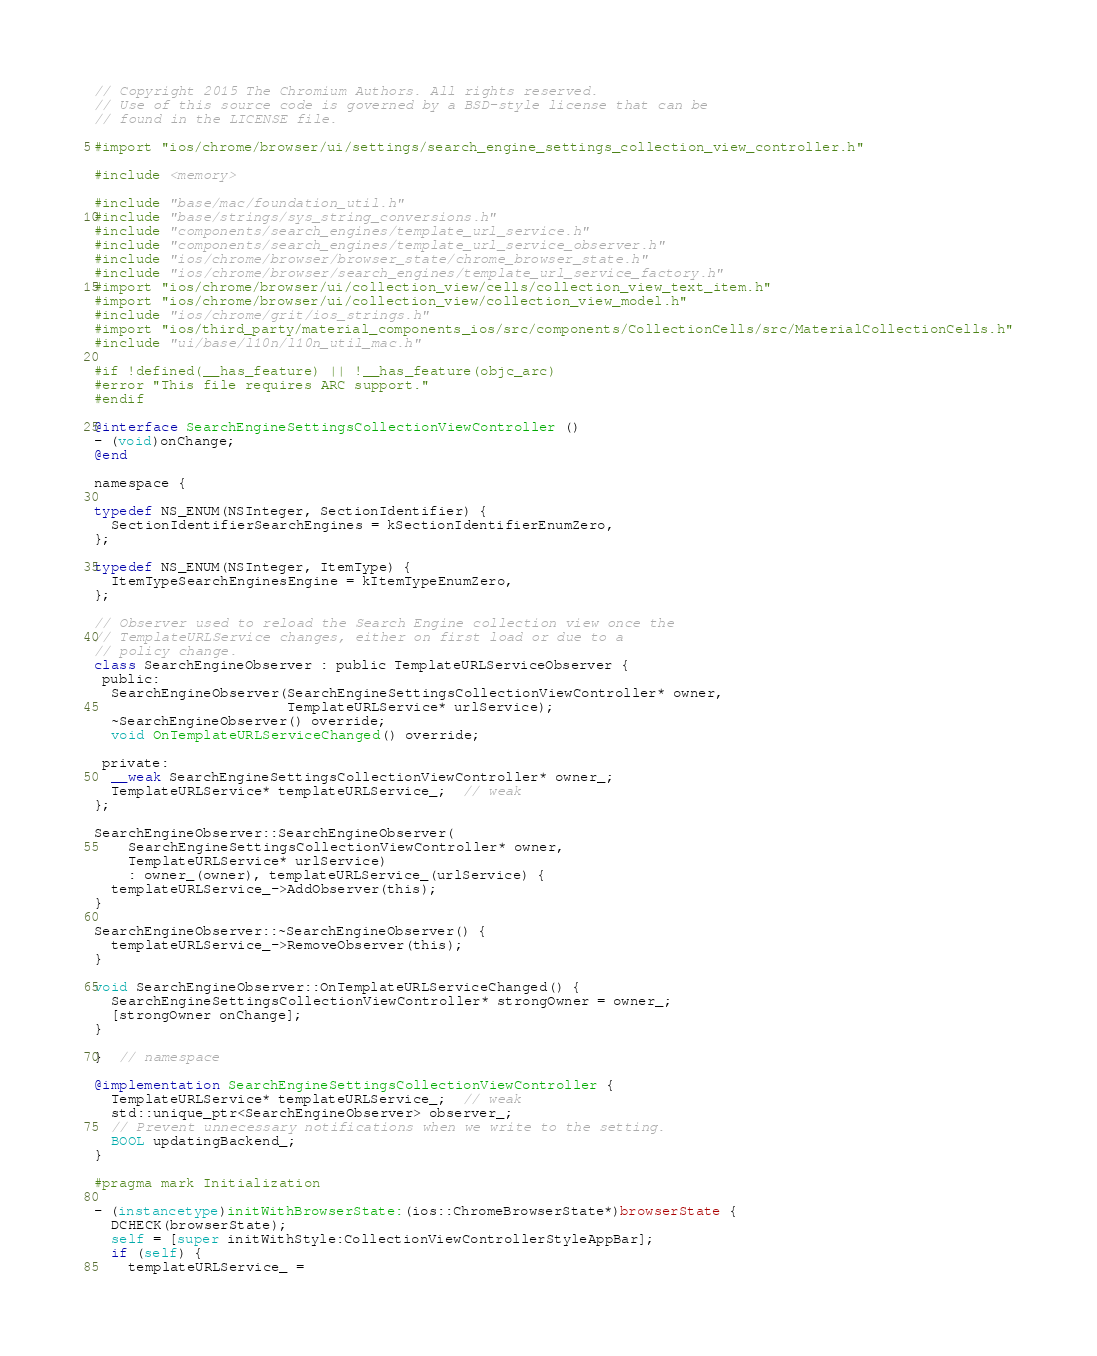Convert code to text. <code><loc_0><loc_0><loc_500><loc_500><_ObjectiveC_>// Copyright 2015 The Chromium Authors. All rights reserved.
// Use of this source code is governed by a BSD-style license that can be
// found in the LICENSE file.

#import "ios/chrome/browser/ui/settings/search_engine_settings_collection_view_controller.h"

#include <memory>

#include "base/mac/foundation_util.h"
#include "base/strings/sys_string_conversions.h"
#include "components/search_engines/template_url_service.h"
#include "components/search_engines/template_url_service_observer.h"
#include "ios/chrome/browser/browser_state/chrome_browser_state.h"
#include "ios/chrome/browser/search_engines/template_url_service_factory.h"
#import "ios/chrome/browser/ui/collection_view/cells/collection_view_text_item.h"
#import "ios/chrome/browser/ui/collection_view/collection_view_model.h"
#include "ios/chrome/grit/ios_strings.h"
#import "ios/third_party/material_components_ios/src/components/CollectionCells/src/MaterialCollectionCells.h"
#include "ui/base/l10n/l10n_util_mac.h"

#if !defined(__has_feature) || !__has_feature(objc_arc)
#error "This file requires ARC support."
#endif

@interface SearchEngineSettingsCollectionViewController ()
- (void)onChange;
@end

namespace {

typedef NS_ENUM(NSInteger, SectionIdentifier) {
  SectionIdentifierSearchEngines = kSectionIdentifierEnumZero,
};

typedef NS_ENUM(NSInteger, ItemType) {
  ItemTypeSearchEnginesEngine = kItemTypeEnumZero,
};

// Observer used to reload the Search Engine collection view once the
// TemplateURLService changes, either on first load or due to a
// policy change.
class SearchEngineObserver : public TemplateURLServiceObserver {
 public:
  SearchEngineObserver(SearchEngineSettingsCollectionViewController* owner,
                       TemplateURLService* urlService);
  ~SearchEngineObserver() override;
  void OnTemplateURLServiceChanged() override;

 private:
  __weak SearchEngineSettingsCollectionViewController* owner_;
  TemplateURLService* templateURLService_;  // weak
};

SearchEngineObserver::SearchEngineObserver(
    SearchEngineSettingsCollectionViewController* owner,
    TemplateURLService* urlService)
    : owner_(owner), templateURLService_(urlService) {
  templateURLService_->AddObserver(this);
}

SearchEngineObserver::~SearchEngineObserver() {
  templateURLService_->RemoveObserver(this);
}

void SearchEngineObserver::OnTemplateURLServiceChanged() {
  SearchEngineSettingsCollectionViewController* strongOwner = owner_;
  [strongOwner onChange];
}

}  // namespace

@implementation SearchEngineSettingsCollectionViewController {
  TemplateURLService* templateURLService_;  // weak
  std::unique_ptr<SearchEngineObserver> observer_;
  // Prevent unnecessary notifications when we write to the setting.
  BOOL updatingBackend_;
}

#pragma mark Initialization

- (instancetype)initWithBrowserState:(ios::ChromeBrowserState*)browserState {
  DCHECK(browserState);
  self = [super initWithStyle:CollectionViewControllerStyleAppBar];
  if (self) {
    templateURLService_ =</code> 